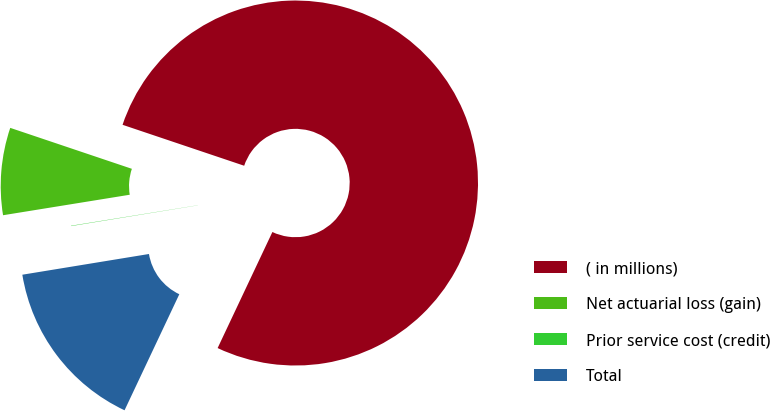Convert chart. <chart><loc_0><loc_0><loc_500><loc_500><pie_chart><fcel>( in millions)<fcel>Net actuarial loss (gain)<fcel>Prior service cost (credit)<fcel>Total<nl><fcel>76.85%<fcel>7.72%<fcel>0.03%<fcel>15.4%<nl></chart> 